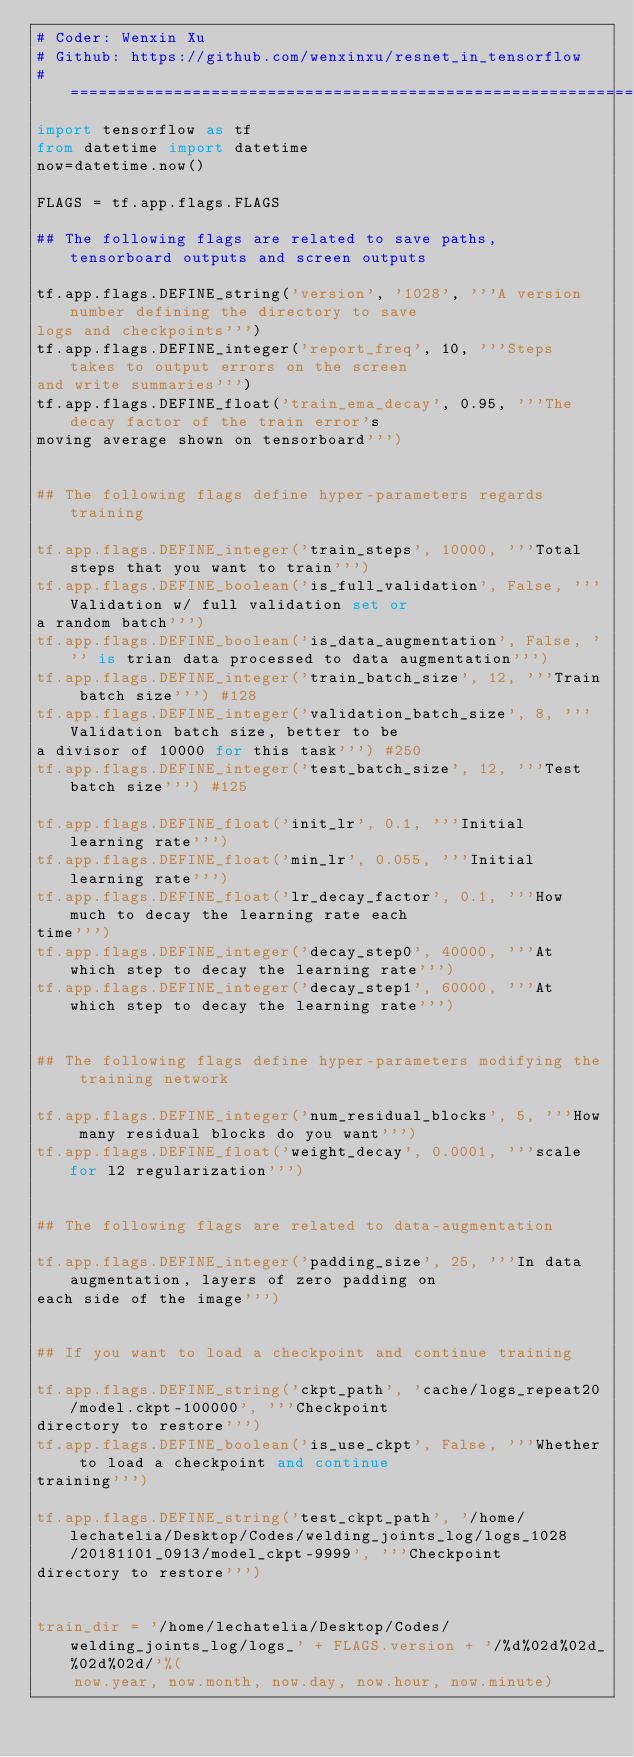Convert code to text. <code><loc_0><loc_0><loc_500><loc_500><_Python_># Coder: Wenxin Xu
# Github: https://github.com/wenxinxu/resnet_in_tensorflow
# ==============================================================================
import tensorflow as tf
from datetime import datetime
now=datetime.now()

FLAGS = tf.app.flags.FLAGS

## The following flags are related to save paths, tensorboard outputs and screen outputs

tf.app.flags.DEFINE_string('version', '1028', '''A version number defining the directory to save
logs and checkpoints''')
tf.app.flags.DEFINE_integer('report_freq', 10, '''Steps takes to output errors on the screen
and write summaries''')
tf.app.flags.DEFINE_float('train_ema_decay', 0.95, '''The decay factor of the train error's
moving average shown on tensorboard''')


## The following flags define hyper-parameters regards training

tf.app.flags.DEFINE_integer('train_steps', 10000, '''Total steps that you want to train''')
tf.app.flags.DEFINE_boolean('is_full_validation', False, '''Validation w/ full validation set or
a random batch''')
tf.app.flags.DEFINE_boolean('is_data_augmentation', False, ''' is trian data processed to data augmentation''')
tf.app.flags.DEFINE_integer('train_batch_size', 12, '''Train batch size''') #128
tf.app.flags.DEFINE_integer('validation_batch_size', 8, '''Validation batch size, better to be
a divisor of 10000 for this task''') #250
tf.app.flags.DEFINE_integer('test_batch_size', 12, '''Test batch size''') #125

tf.app.flags.DEFINE_float('init_lr', 0.1, '''Initial learning rate''')
tf.app.flags.DEFINE_float('min_lr', 0.055, '''Initial learning rate''')
tf.app.flags.DEFINE_float('lr_decay_factor', 0.1, '''How much to decay the learning rate each
time''')
tf.app.flags.DEFINE_integer('decay_step0', 40000, '''At which step to decay the learning rate''')
tf.app.flags.DEFINE_integer('decay_step1', 60000, '''At which step to decay the learning rate''')


## The following flags define hyper-parameters modifying the training network

tf.app.flags.DEFINE_integer('num_residual_blocks', 5, '''How many residual blocks do you want''')
tf.app.flags.DEFINE_float('weight_decay', 0.0001, '''scale for l2 regularization''')


## The following flags are related to data-augmentation

tf.app.flags.DEFINE_integer('padding_size', 25, '''In data augmentation, layers of zero padding on
each side of the image''')


## If you want to load a checkpoint and continue training

tf.app.flags.DEFINE_string('ckpt_path', 'cache/logs_repeat20/model.ckpt-100000', '''Checkpoint
directory to restore''')
tf.app.flags.DEFINE_boolean('is_use_ckpt', False, '''Whether to load a checkpoint and continue
training''')

tf.app.flags.DEFINE_string('test_ckpt_path', '/home/lechatelia/Desktop/Codes/welding_joints_log/logs_1028/20181101_0913/model_ckpt-9999', '''Checkpoint
directory to restore''')


train_dir = '/home/lechatelia/Desktop/Codes/welding_joints_log/logs_' + FLAGS.version + '/%d%02d%02d_%02d%02d/'%(
    now.year, now.month, now.day, now.hour, now.minute)
</code> 